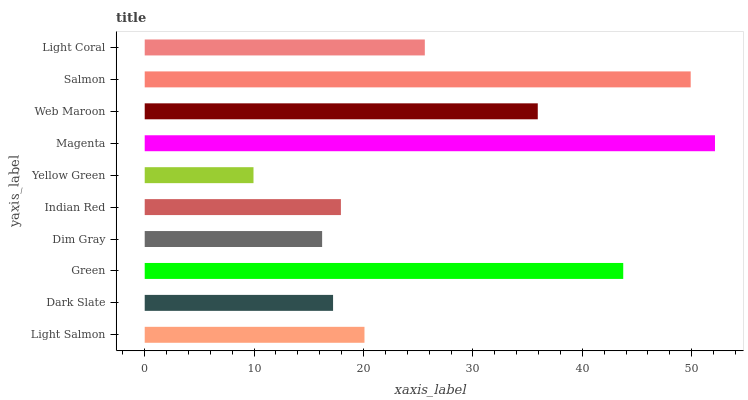Is Yellow Green the minimum?
Answer yes or no. Yes. Is Magenta the maximum?
Answer yes or no. Yes. Is Dark Slate the minimum?
Answer yes or no. No. Is Dark Slate the maximum?
Answer yes or no. No. Is Light Salmon greater than Dark Slate?
Answer yes or no. Yes. Is Dark Slate less than Light Salmon?
Answer yes or no. Yes. Is Dark Slate greater than Light Salmon?
Answer yes or no. No. Is Light Salmon less than Dark Slate?
Answer yes or no. No. Is Light Coral the high median?
Answer yes or no. Yes. Is Light Salmon the low median?
Answer yes or no. Yes. Is Yellow Green the high median?
Answer yes or no. No. Is Salmon the low median?
Answer yes or no. No. 